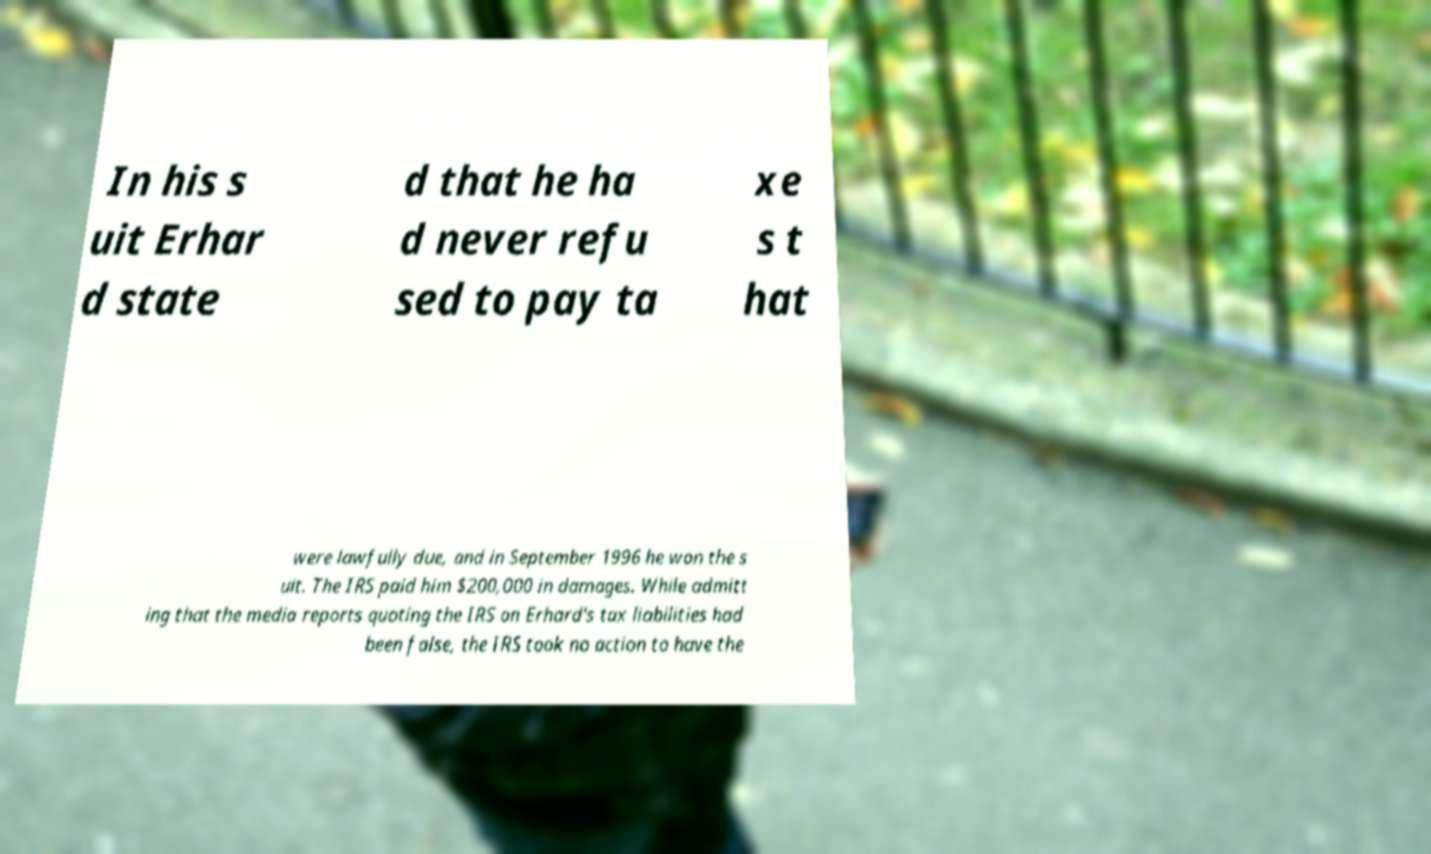There's text embedded in this image that I need extracted. Can you transcribe it verbatim? In his s uit Erhar d state d that he ha d never refu sed to pay ta xe s t hat were lawfully due, and in September 1996 he won the s uit. The IRS paid him $200,000 in damages. While admitt ing that the media reports quoting the IRS on Erhard's tax liabilities had been false, the IRS took no action to have the 